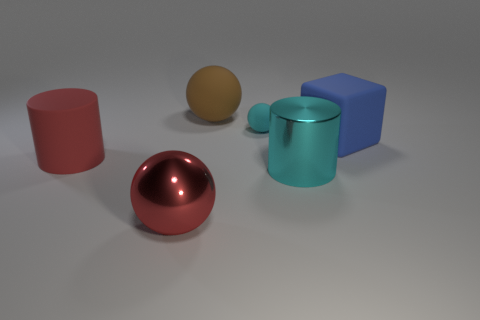Subtract all small cyan matte spheres. How many spheres are left? 2 Add 3 big brown balls. How many objects exist? 9 Subtract all cylinders. How many objects are left? 4 Subtract 1 blocks. How many blocks are left? 0 Add 3 cyan spheres. How many cyan spheres are left? 4 Add 4 cyan shiny blocks. How many cyan shiny blocks exist? 4 Subtract all cyan cylinders. How many cylinders are left? 1 Subtract 1 blue cubes. How many objects are left? 5 Subtract all green cylinders. Subtract all gray cubes. How many cylinders are left? 2 Subtract all brown cylinders. Subtract all cyan metal things. How many objects are left? 5 